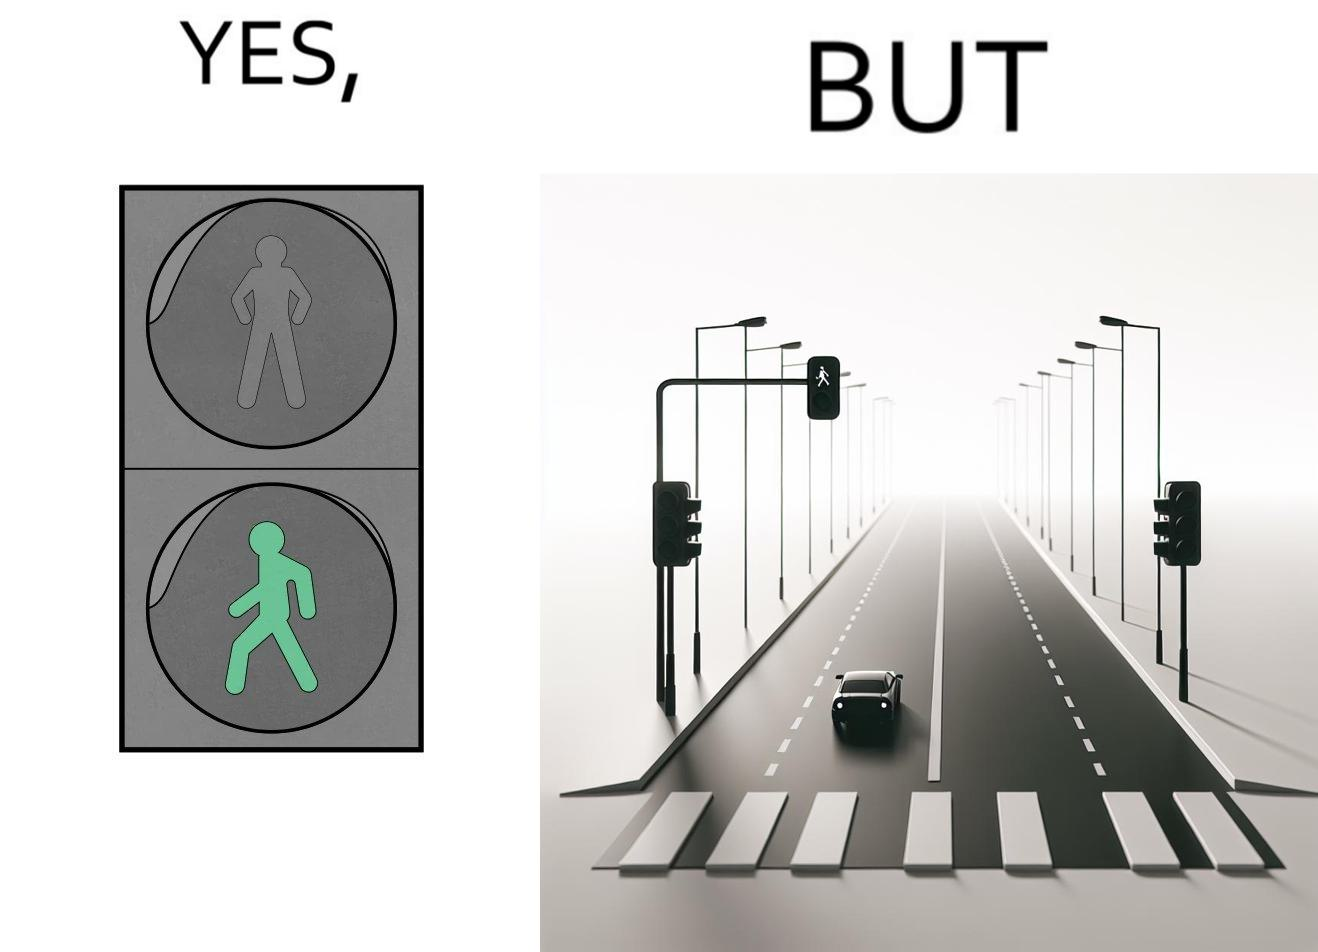Describe what you see in the left and right parts of this image. In the left part of the image: The image shows the walk sign turned to green on a traffic signal. In the right part of the image: The image shows an empty road with only one car on the road. The car is waiting for the walk sign to turn to red so that it can cross the zebra crossing.  There is no one else on the road except from the car. 